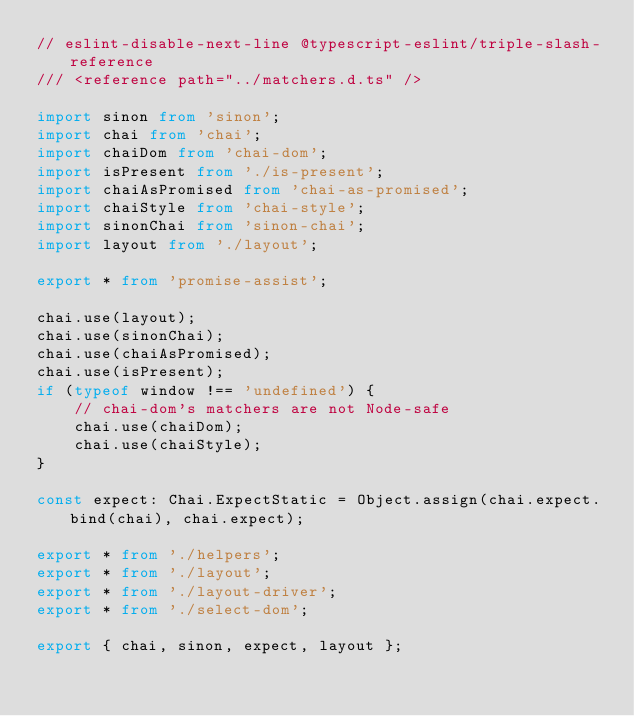<code> <loc_0><loc_0><loc_500><loc_500><_TypeScript_>// eslint-disable-next-line @typescript-eslint/triple-slash-reference
/// <reference path="../matchers.d.ts" />

import sinon from 'sinon';
import chai from 'chai';
import chaiDom from 'chai-dom';
import isPresent from './is-present';
import chaiAsPromised from 'chai-as-promised';
import chaiStyle from 'chai-style';
import sinonChai from 'sinon-chai';
import layout from './layout';

export * from 'promise-assist';

chai.use(layout);
chai.use(sinonChai);
chai.use(chaiAsPromised);
chai.use(isPresent);
if (typeof window !== 'undefined') {
    // chai-dom's matchers are not Node-safe
    chai.use(chaiDom);
    chai.use(chaiStyle);
}

const expect: Chai.ExpectStatic = Object.assign(chai.expect.bind(chai), chai.expect);

export * from './helpers';
export * from './layout';
export * from './layout-driver';
export * from './select-dom';

export { chai, sinon, expect, layout };
</code> 